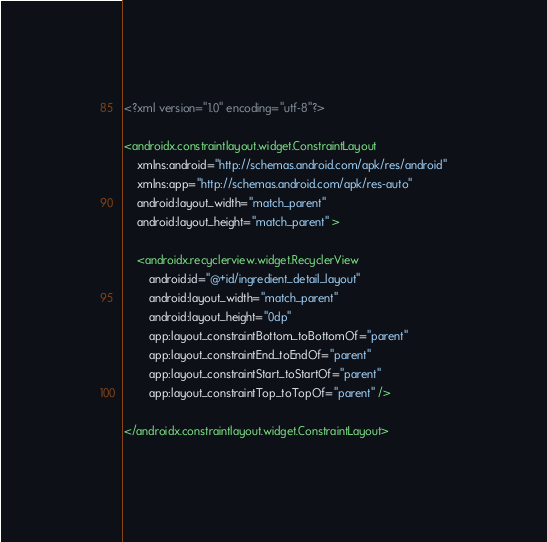Convert code to text. <code><loc_0><loc_0><loc_500><loc_500><_XML_><?xml version="1.0" encoding="utf-8"?>

<androidx.constraintlayout.widget.ConstraintLayout
    xmlns:android="http://schemas.android.com/apk/res/android"
    xmlns:app="http://schemas.android.com/apk/res-auto"
    android:layout_width="match_parent"
    android:layout_height="match_parent" >

    <androidx.recyclerview.widget.RecyclerView
        android:id="@+id/ingredient_detail_layout"
        android:layout_width="match_parent"
        android:layout_height="0dp"
        app:layout_constraintBottom_toBottomOf="parent"
        app:layout_constraintEnd_toEndOf="parent"
        app:layout_constraintStart_toStartOf="parent"
        app:layout_constraintTop_toTopOf="parent" />

</androidx.constraintlayout.widget.ConstraintLayout></code> 